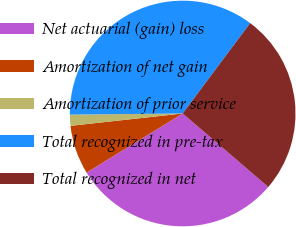Convert chart to OTSL. <chart><loc_0><loc_0><loc_500><loc_500><pie_chart><fcel>Net actuarial (gain) loss<fcel>Amortization of net gain<fcel>Amortization of prior service<fcel>Total recognized in pre-tax<fcel>Total recognized in net<nl><fcel>29.93%<fcel>7.03%<fcel>1.59%<fcel>35.37%<fcel>26.08%<nl></chart> 